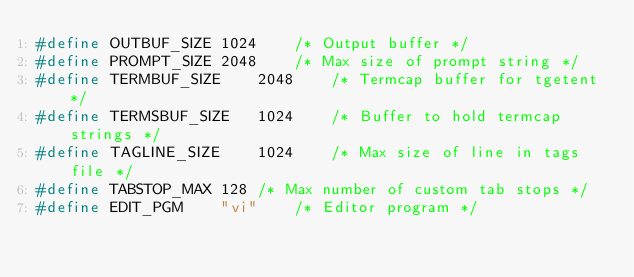Convert code to text. <code><loc_0><loc_0><loc_500><loc_500><_C_>#define	OUTBUF_SIZE	1024	/* Output buffer */
#define	PROMPT_SIZE	2048	/* Max size of prompt string */
#define	TERMBUF_SIZE	2048	/* Termcap buffer for tgetent */
#define	TERMSBUF_SIZE	1024	/* Buffer to hold termcap strings */
#define	TAGLINE_SIZE	1024	/* Max size of line in tags file */
#define	TABSTOP_MAX	128	/* Max number of custom tab stops */
#define	EDIT_PGM	"vi"	/* Editor program */
</code> 